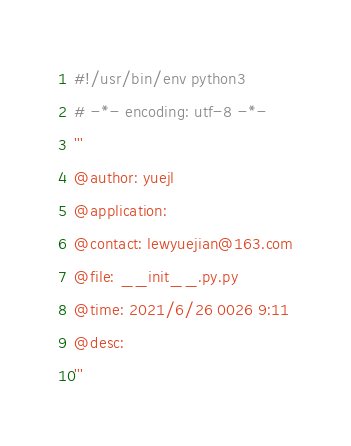<code> <loc_0><loc_0><loc_500><loc_500><_Python_>#!/usr/bin/env python3
# -*- encoding: utf-8 -*-
'''
@author: yuejl
@application:
@contact: lewyuejian@163.com
@file: __init__.py.py
@time: 2021/6/26 0026 9:11
@desc:
'''</code> 